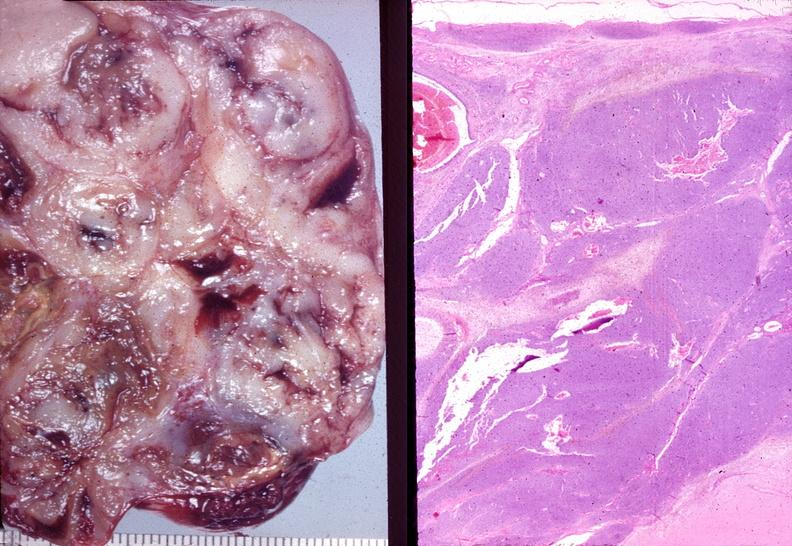where is this from?
Answer the question using a single word or phrase. Female reproductive system 